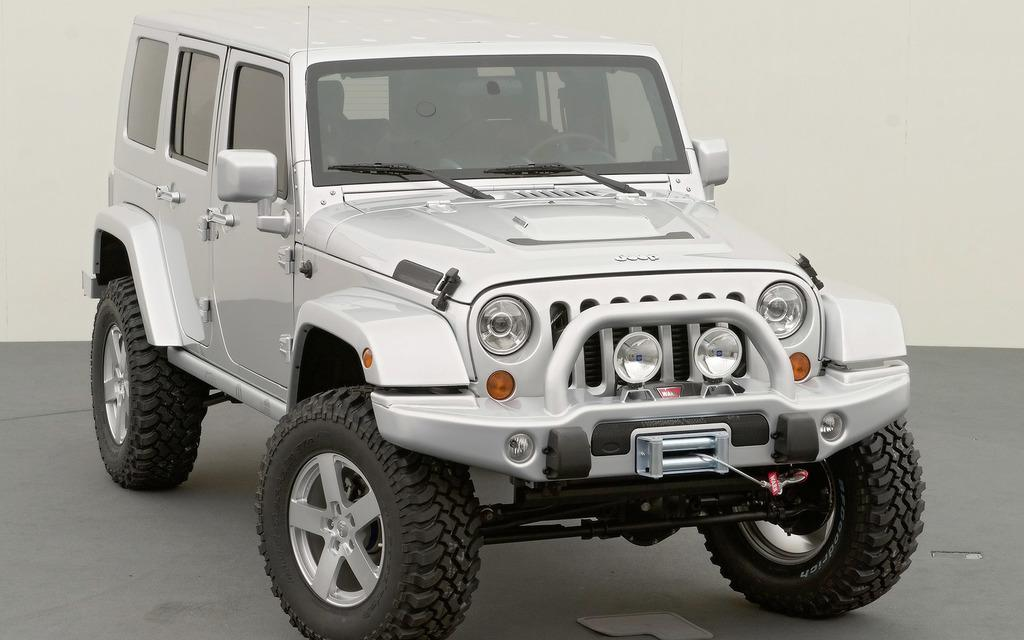What is the main subject in the center of the image? There is a jeep in the center of the image. What is the surface beneath the jeep? There is a floor at the bottom of the image. What can be seen in the background of the image? There is a wall in the background of the image. What type of current can be seen flowing through the jeep in the image? There is no current flowing through the jeep in the image; it is a stationary vehicle. 